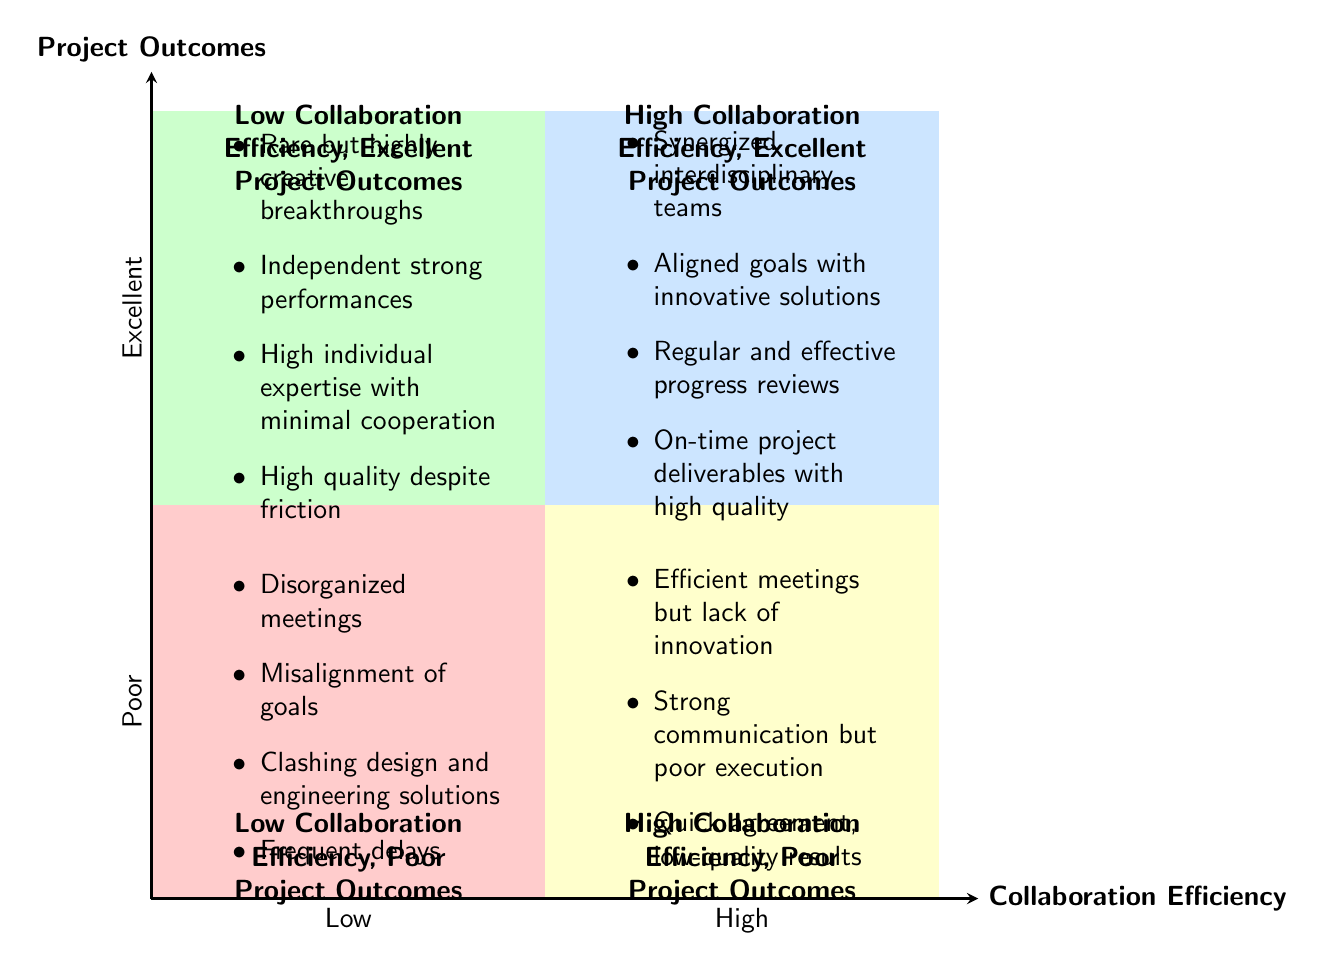What is located in the High Collaboration Efficiency, Poor Project Outcomes quadrant? The High Collaboration Efficiency, Poor Project Outcomes quadrant contains elements that indicate strong communication but lack effective results, such as "Efficient meetings but lack of innovation," "Strong communication but poor execution," and "Quick agreement, low-quality results."
Answer: Efficient meetings but lack of innovation, Strong communication but poor execution, Quick agreement, low-quality results How many elements are there in the Low Collaboration Efficiency, Excellent Project Outcomes quadrant? The Low Collaboration Efficiency, Excellent Project Outcomes quadrant includes four specific elements: "Rare but highly creative breakthroughs," "Independent strong performances," "High individual expertise with minimal cooperation," and "High quality despite friction," resulting in four total elements.
Answer: 4 Which quadrant contains "Synergized interdisciplinary teams"? "Synergized interdisciplinary teams" is located in the High Collaboration Efficiency, Excellent Project Outcomes quadrant, as it describes an effective collaborative environment yielding excellent results.
Answer: High Collaboration Efficiency, Excellent Project Outcomes What do the elements in the Low Collaboration Efficiency, Poor Project Outcomes quadrant suggest? The elements in this quadrant suggest that when collaboration is low, the outcomes are poor, characterized by disorganized meetings, misalignment of goals, and clashes between design and engineering solutions.
Answer: Disorganized meetings, Misalignment of goals, Clashing design and engineering solutions, Frequent delays Which quadrant represents a situation where project goals are misaligned? A situation where project goals are misaligned is represented in the Low Collaboration Efficiency, Poor Project Outcomes quadrant, indicating ineffective collaboration leading to poor results.
Answer: Low Collaboration Efficiency, Poor Project Outcomes 